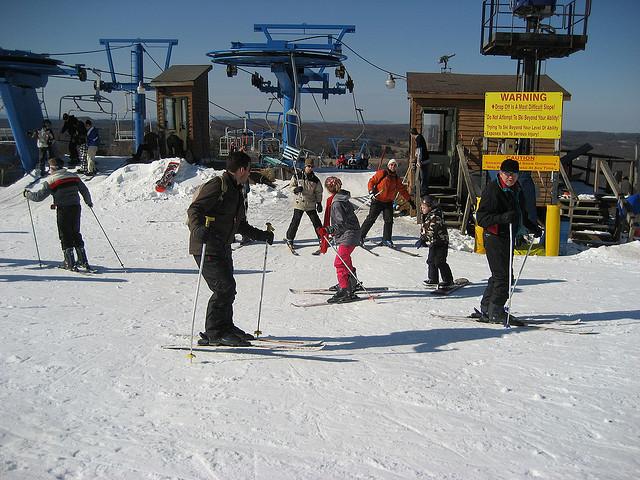Is there a restaurant on this hill?
Write a very short answer. No. What message is given to the skiers?
Short answer required. Warning. Are they snowboarding?
Short answer required. No. How many people are standing?
Short answer required. 7. Are these people dressed for the weather?
Keep it brief. Yes. Are there any people on the ski lift?
Write a very short answer. Yes. 